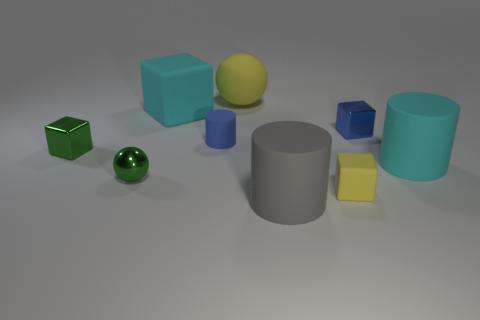Subtract 1 blocks. How many blocks are left? 3 Add 1 small cubes. How many objects exist? 10 Subtract all cylinders. How many objects are left? 6 Subtract all green metal spheres. Subtract all small matte blocks. How many objects are left? 7 Add 3 gray rubber objects. How many gray rubber objects are left? 4 Add 5 yellow objects. How many yellow objects exist? 7 Subtract 0 brown balls. How many objects are left? 9 